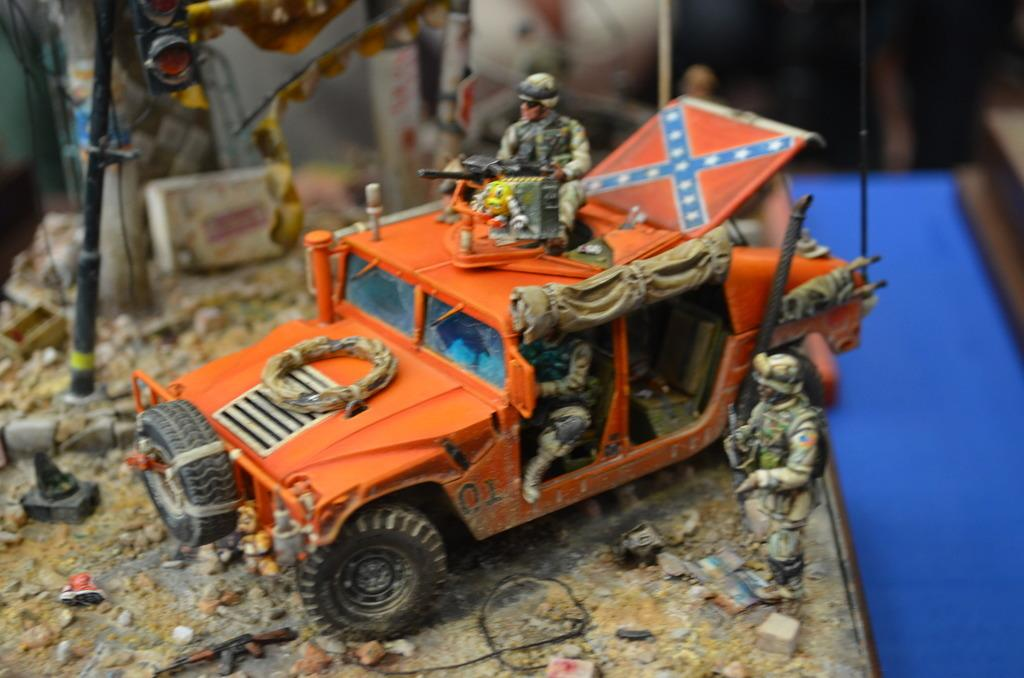What type of toy can be seen in the image? There is a toy vehicle in the image. What other types of toys are present in the image? There are toys of soldiers in the image. Where are the toys located? The toys are on a table. Can you describe the background of the toys? The background of the toys is blurred. How does the cap slip off the toy vehicle in the image? There is no cap present on the toy vehicle in the image, so it cannot slip off. 